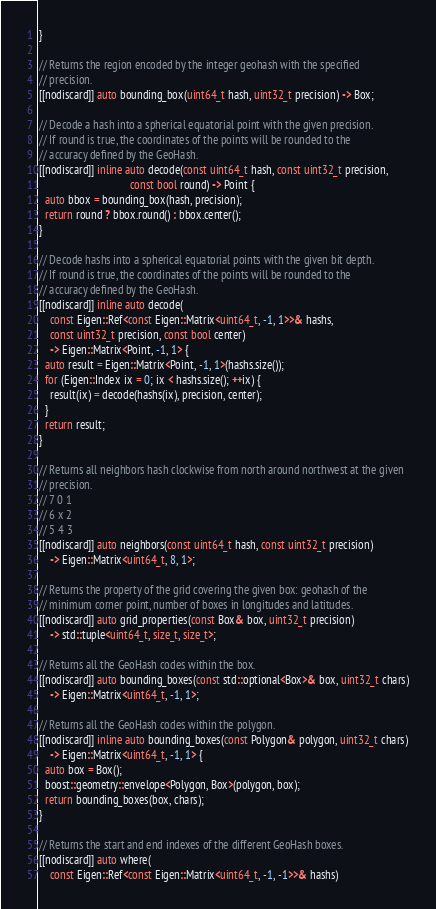<code> <loc_0><loc_0><loc_500><loc_500><_C++_>}

// Returns the region encoded by the integer geohash with the specified
// precision.
[[nodiscard]] auto bounding_box(uint64_t hash, uint32_t precision) -> Box;

// Decode a hash into a spherical equatorial point with the given precision.
// If round is true, the coordinates of the points will be rounded to the
// accuracy defined by the GeoHash.
[[nodiscard]] inline auto decode(const uint64_t hash, const uint32_t precision,
                                 const bool round) -> Point {
  auto bbox = bounding_box(hash, precision);
  return round ? bbox.round() : bbox.center();
}

// Decode hashs into a spherical equatorial points with the given bit depth.
// If round is true, the coordinates of the points will be rounded to the
// accuracy defined by the GeoHash.
[[nodiscard]] inline auto decode(
    const Eigen::Ref<const Eigen::Matrix<uint64_t, -1, 1>>& hashs,
    const uint32_t precision, const bool center)
    -> Eigen::Matrix<Point, -1, 1> {
  auto result = Eigen::Matrix<Point, -1, 1>(hashs.size());
  for (Eigen::Index ix = 0; ix < hashs.size(); ++ix) {
    result(ix) = decode(hashs(ix), precision, center);
  }
  return result;
}

// Returns all neighbors hash clockwise from north around northwest at the given
// precision.
// 7 0 1
// 6 x 2
// 5 4 3
[[nodiscard]] auto neighbors(const uint64_t hash, const uint32_t precision)
    -> Eigen::Matrix<uint64_t, 8, 1>;

// Returns the property of the grid covering the given box: geohash of the
// minimum corner point, number of boxes in longitudes and latitudes.
[[nodiscard]] auto grid_properties(const Box& box, uint32_t precision)
    -> std::tuple<uint64_t, size_t, size_t>;

// Returns all the GeoHash codes within the box.
[[nodiscard]] auto bounding_boxes(const std::optional<Box>& box, uint32_t chars)
    -> Eigen::Matrix<uint64_t, -1, 1>;

// Returns all the GeoHash codes within the polygon.
[[nodiscard]] inline auto bounding_boxes(const Polygon& polygon, uint32_t chars)
    -> Eigen::Matrix<uint64_t, -1, 1> {
  auto box = Box();
  boost::geometry::envelope<Polygon, Box>(polygon, box);
  return bounding_boxes(box, chars);
}

// Returns the start and end indexes of the different GeoHash boxes.
[[nodiscard]] auto where(
    const Eigen::Ref<const Eigen::Matrix<uint64_t, -1, -1>>& hashs)</code> 